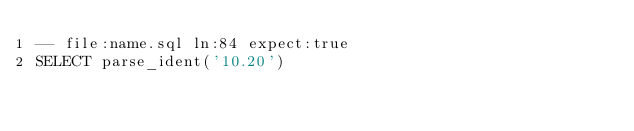Convert code to text. <code><loc_0><loc_0><loc_500><loc_500><_SQL_>-- file:name.sql ln:84 expect:true
SELECT parse_ident('10.20')
</code> 